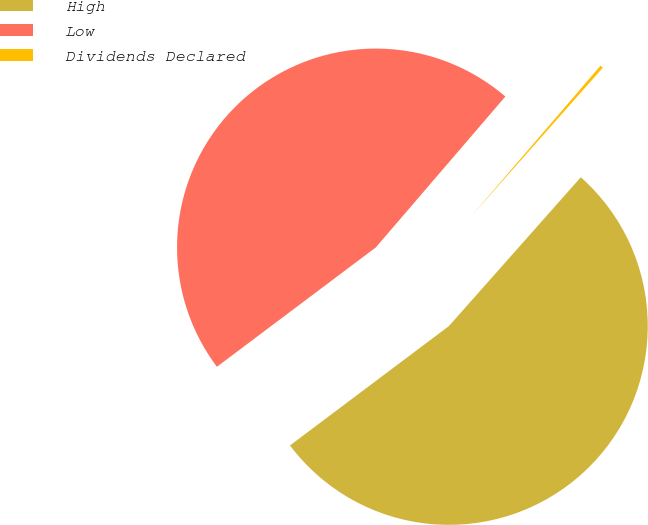Convert chart to OTSL. <chart><loc_0><loc_0><loc_500><loc_500><pie_chart><fcel>High<fcel>Low<fcel>Dividends Declared<nl><fcel>53.2%<fcel>46.54%<fcel>0.25%<nl></chart> 